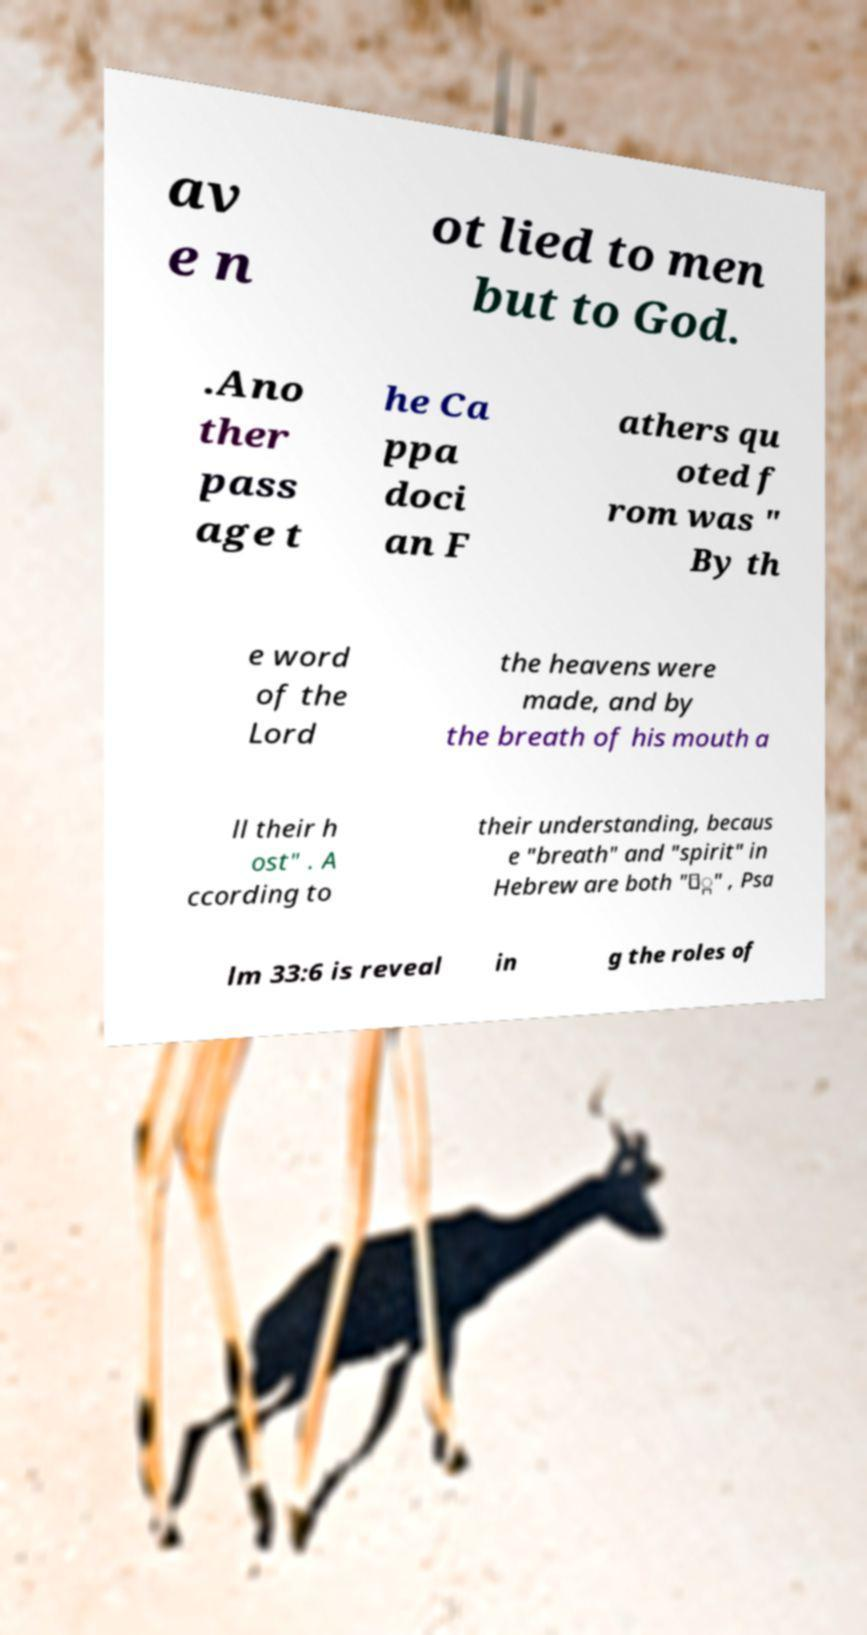Please read and relay the text visible in this image. What does it say? av e n ot lied to men but to God. .Ano ther pass age t he Ca ppa doci an F athers qu oted f rom was " By th e word of the Lord the heavens were made, and by the breath of his mouth a ll their h ost" . A ccording to their understanding, becaus e "breath" and "spirit" in Hebrew are both "ַּ" , Psa lm 33:6 is reveal in g the roles of 